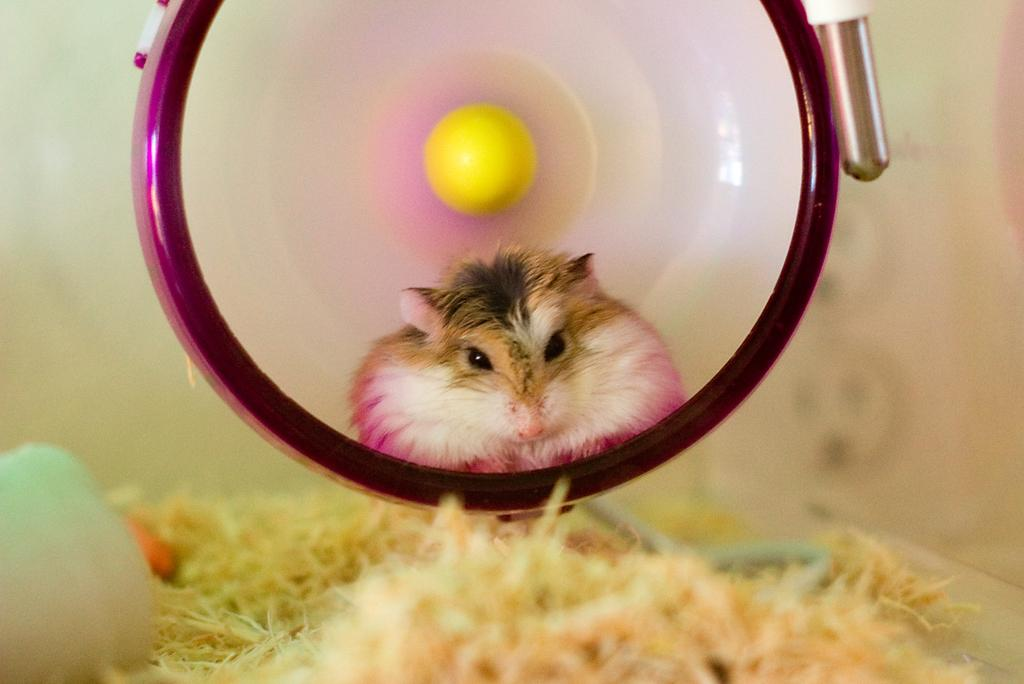What type of living creature is in the picture? There is an animal in the picture. What else can be seen in the image besides the animal? There are objects in the picture. Can you describe the background of the image? The background of the image is blurred. How many cats are sitting on the earth in the image? There is no mention of cats or the earth in the image; it only contains an animal and objects. 